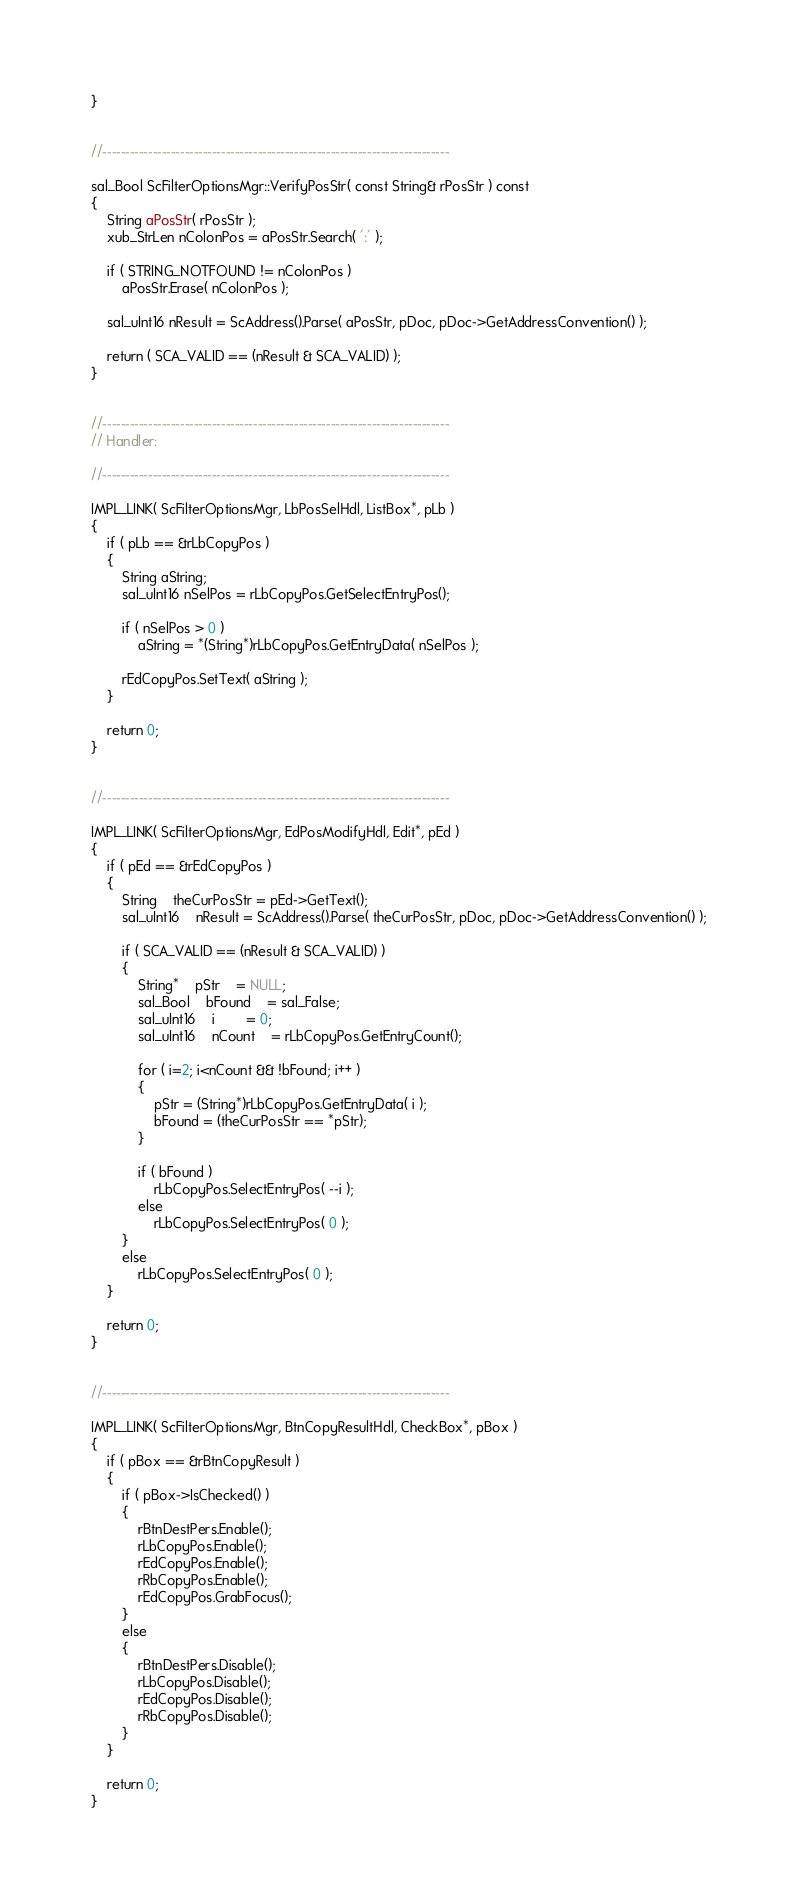<code> <loc_0><loc_0><loc_500><loc_500><_C++_>}


//----------------------------------------------------------------------------

sal_Bool ScFilterOptionsMgr::VerifyPosStr( const String& rPosStr ) const
{
	String aPosStr( rPosStr );
	xub_StrLen nColonPos = aPosStr.Search( ':' );

	if ( STRING_NOTFOUND != nColonPos )
		aPosStr.Erase( nColonPos );

	sal_uInt16 nResult = ScAddress().Parse( aPosStr, pDoc, pDoc->GetAddressConvention() );

	return ( SCA_VALID == (nResult & SCA_VALID) );
}


//----------------------------------------------------------------------------
// Handler:

//----------------------------------------------------------------------------

IMPL_LINK( ScFilterOptionsMgr, LbPosSelHdl, ListBox*, pLb )
{
	if ( pLb == &rLbCopyPos )
	{
		String aString;
		sal_uInt16 nSelPos = rLbCopyPos.GetSelectEntryPos();

		if ( nSelPos > 0 )
			aString = *(String*)rLbCopyPos.GetEntryData( nSelPos );

		rEdCopyPos.SetText( aString );
	}

	return 0;
}


//----------------------------------------------------------------------------

IMPL_LINK( ScFilterOptionsMgr, EdPosModifyHdl, Edit*, pEd )
{
	if ( pEd == &rEdCopyPos )
	{
		String	theCurPosStr = pEd->GetText();
		sal_uInt16	nResult = ScAddress().Parse( theCurPosStr, pDoc, pDoc->GetAddressConvention() );

		if ( SCA_VALID == (nResult & SCA_VALID) )
		{
			String*	pStr	= NULL;
			sal_Bool	bFound	= sal_False;
			sal_uInt16	i		= 0;
			sal_uInt16	nCount	= rLbCopyPos.GetEntryCount();

			for ( i=2; i<nCount && !bFound; i++ )
			{
				pStr = (String*)rLbCopyPos.GetEntryData( i );
				bFound = (theCurPosStr == *pStr);
			}

			if ( bFound )
				rLbCopyPos.SelectEntryPos( --i );
			else
				rLbCopyPos.SelectEntryPos( 0 );
		}
		else
			rLbCopyPos.SelectEntryPos( 0 );
	}

	return 0;
}


//----------------------------------------------------------------------------

IMPL_LINK( ScFilterOptionsMgr, BtnCopyResultHdl, CheckBox*, pBox )
{
	if ( pBox == &rBtnCopyResult )
	{
		if ( pBox->IsChecked() )
		{
			rBtnDestPers.Enable();
			rLbCopyPos.Enable();
			rEdCopyPos.Enable();
			rRbCopyPos.Enable();
			rEdCopyPos.GrabFocus();
		}
		else
		{
			rBtnDestPers.Disable();
			rLbCopyPos.Disable();
			rEdCopyPos.Disable();
			rRbCopyPos.Disable();
		}
	}

	return 0;
}
</code> 